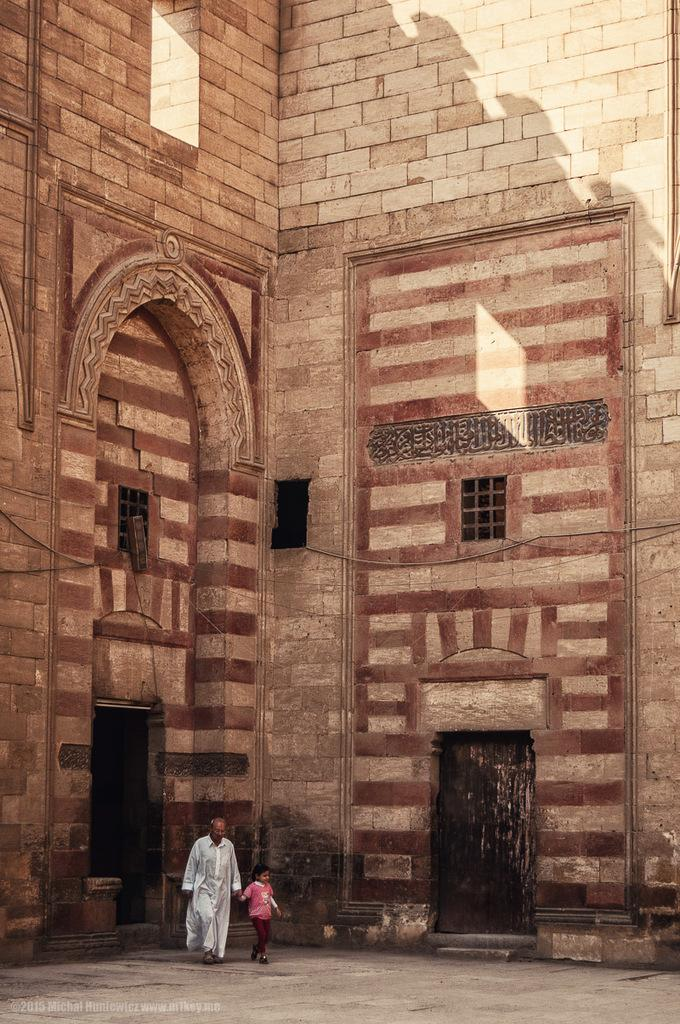Who is the main subject in the image? The main subject in the image is an old man. What is the old man doing in the image? The old man is walking on the floor. Is there anyone else in the image? Yes, there is a kid in the image. What is the kid doing in the image? The kid is walking alongside the old man. What can be seen in the background of the image? There is a building in the background of the image. Where is the door located in the image? The door is on the right side bottom of the image. How many dogs are present in the image? There are no dogs present in the image. Who is the owner of the sky in the image? The sky does not have an owner, as it is a natural phenomenon. 